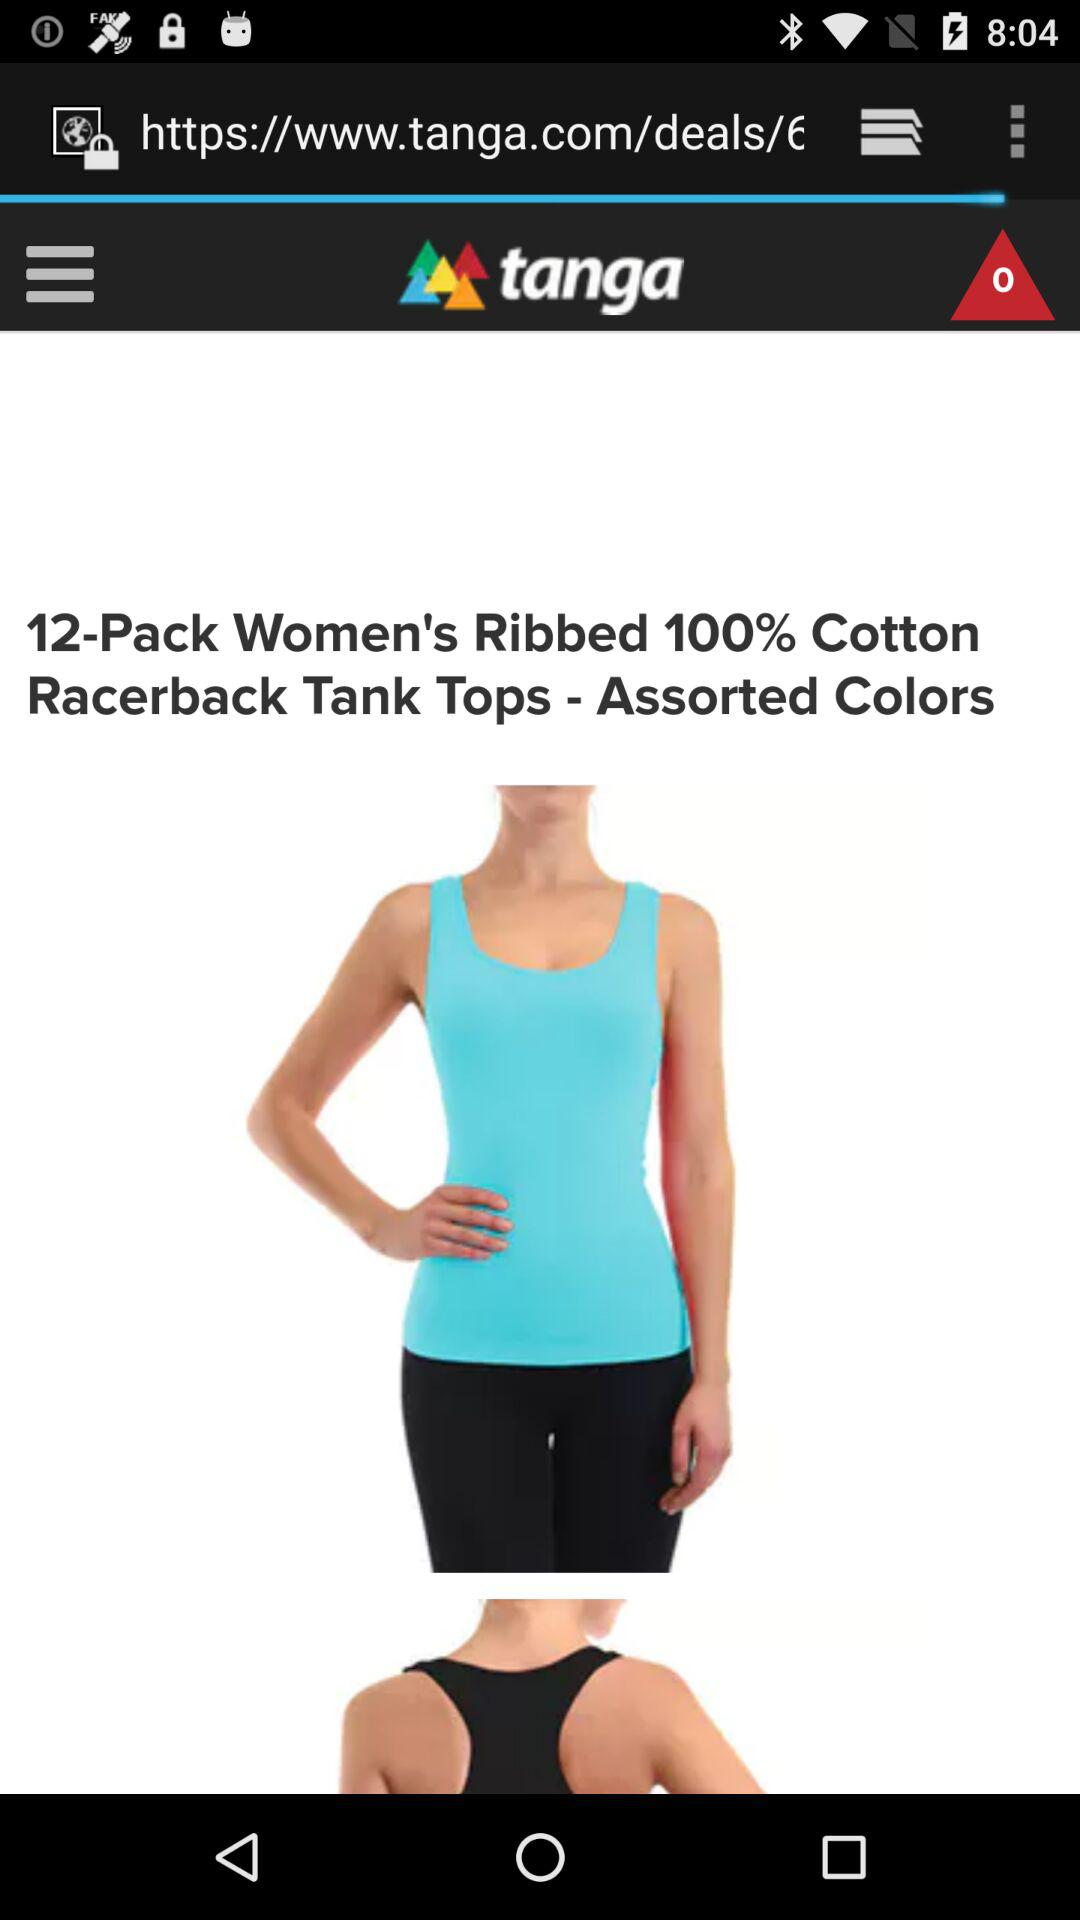How many notifications are shown? There are 0 notifications. 